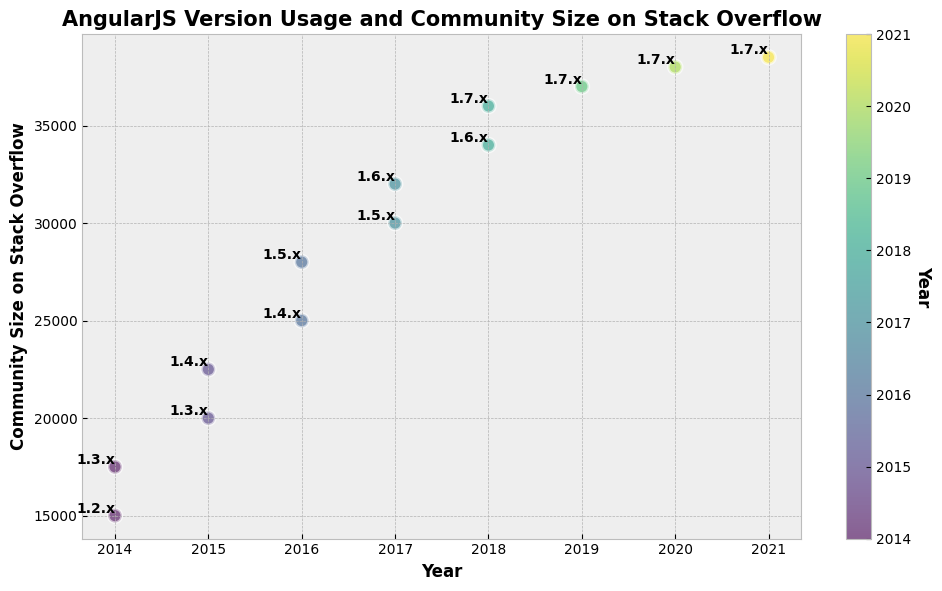What is the community size on Stack Overflow for AngularJS version 1.5.x in 2017? The figure shows that the community size for AngularJS version 1.5.x in 2017 is marked at 30,000.
Answer: 30,000 Which AngularJS version had the highest community size on Stack Overflow, and what was that size? The figure indicates the largest community size points to be 38,500 for AngularJS version 1.7.x in 2021, which is the highest plotted value.
Answer: 1.7.x, 38,500 How did the community size on Stack Overflow change for AngularJS version 1.7.x from 2018 to 2021? By observing the figure, the community size increased from 36,000 in 2018 to 38,500 in 2021, an increase of 2,500.
Answer: Increased by 2,500 Compare the community sizes on Stack Overflow for AngularJS versions 1.4.x and 1.6.x in their respective highest years. Which version had a larger community and by how much? The highest community size for version 1.4.x is in 2016 at 25,000, and for version 1.6.x in 2018 at 34,000. The difference is 34,000 - 25,000 = 9,000 in favor of version 1.6.x.
Answer: 1.6.x, 9,000 more What is the community size trend for AngularJS version 1.3.x from 2014 to 2015? From the figure, the community size for AngularJS version 1.3.x grows from 17,500 in 2014 to 20,000 in 2015, indicating an upward trend.
Answer: Upward Based on the color shading, which year saw the highest number of different AngularJS versions in use? Observing the figure's color gradient, 2017 shows multiple versions (1.5.x and 1.6.x) being used.
Answer: 2017 What was the community size on Stack Overflow in 2015 for the most recent AngularJS version used in that year? The figure shows that 1.4.x was the most recent AngularJS version in 2015, with a community size of 22,500.
Answer: 22,500 Calculate the average community size on Stack Overflow for AngularJS version 1.7.x across all available years. Summing up the community sizes for AngularJS version 1.7.x across the years (36,000 + 37,000 + 38,000 + 38,500) results in 149,500. Dividing this by the four years gives an average community size of 37,375.
Answer: 37,375 Which year featured the introduction of AngularJS version 1.6.x, and what was the corresponding community size? The figure shows the introduction of AngularJS version 1.6.x in 2017 with a community size of 32,000.
Answer: 2017, 32,000 What is the trend in community size for AngularJS versions from 2014 to 2021 overall? The general trend observed in the figure from 2014 to 2021 suggests a consistent increase in community size over the years for the different versions, reflecting growing interest and usage.
Answer: Increasing 